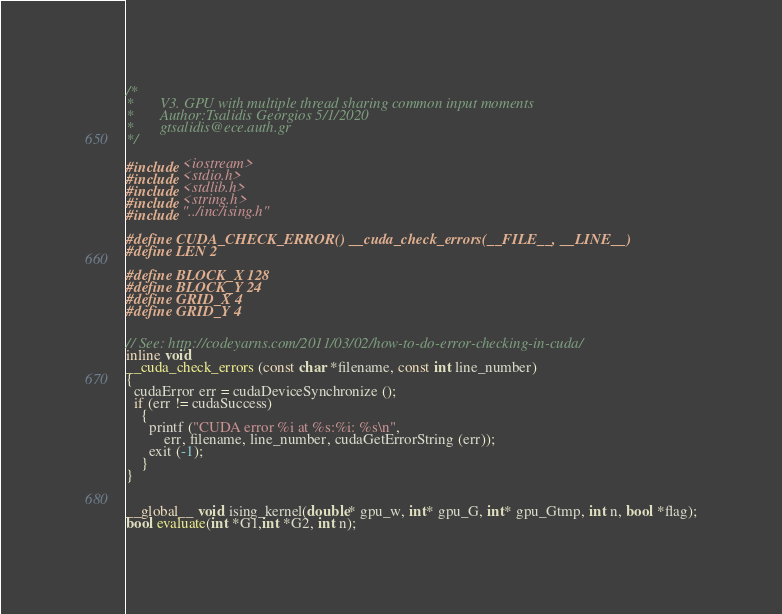<code> <loc_0><loc_0><loc_500><loc_500><_Cuda_>/*
*       V3. GPU with multiple thread sharing common input moments
*       Author:Tsalidis Georgios 5/1/2020
*       gtsalidis@ece.auth.gr
*/

#include <iostream>
#include <stdio.h>
#include <stdlib.h>
#include <string.h>
#include "../inc/ising.h"

#define CUDA_CHECK_ERROR() __cuda_check_errors(__FILE__, __LINE__)
#define LEN 2

#define BLOCK_X 128
#define BLOCK_Y 24
#define GRID_X 4
#define GRID_Y 4


// See: http://codeyarns.com/2011/03/02/how-to-do-error-checking-in-cuda/
inline void
__cuda_check_errors (const char *filename, const int line_number)
{
  cudaError err = cudaDeviceSynchronize ();
  if (err != cudaSuccess)
    {
      printf ("CUDA error %i at %s:%i: %s\n",
          err, filename, line_number, cudaGetErrorString (err));
      exit (-1);
    }
}


__global__ void ising_kernel(double* gpu_w, int* gpu_G, int* gpu_Gtmp, int n, bool *flag);
bool evaluate(int *G1,int *G2, int n);

</code> 